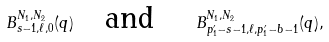Convert formula to latex. <formula><loc_0><loc_0><loc_500><loc_500>\ B _ { s - 1 , \ell , 0 } ^ { N _ { 1 } , N _ { 2 } } ( q ) \quad \text {and} \quad \ B _ { p _ { 1 } ^ { \prime } - s - 1 , \ell , p _ { 1 } ^ { \prime } - b - 1 } ^ { N _ { 1 } , N _ { 2 } } ( q ) ,</formula> 